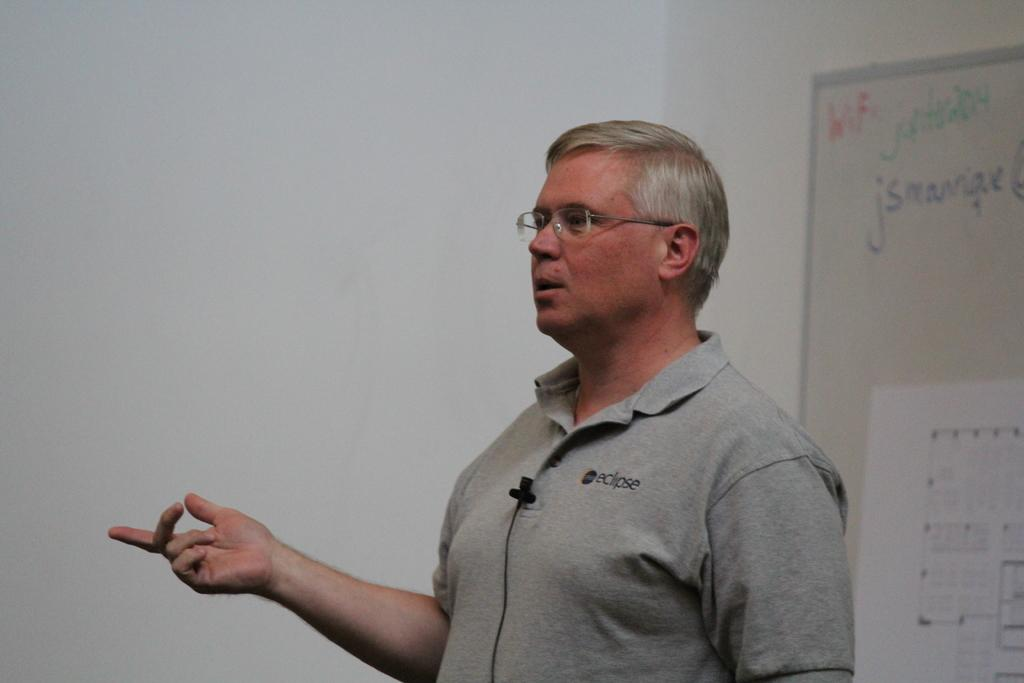Who is the main subject in the image? There is a man in the image. What is the man doing in the image? The man is speaking into a microphone. What is the man wearing in the image? The man is wearing a t-shirt. What can be seen on the right side of the image? There is a board on the right side of the image. Can you see any basketball players on the farm in the image? There is no reference to a farm or basketball players in the image; it features a man speaking into a microphone while wearing a t-shirt, and there is a board on the right side. 